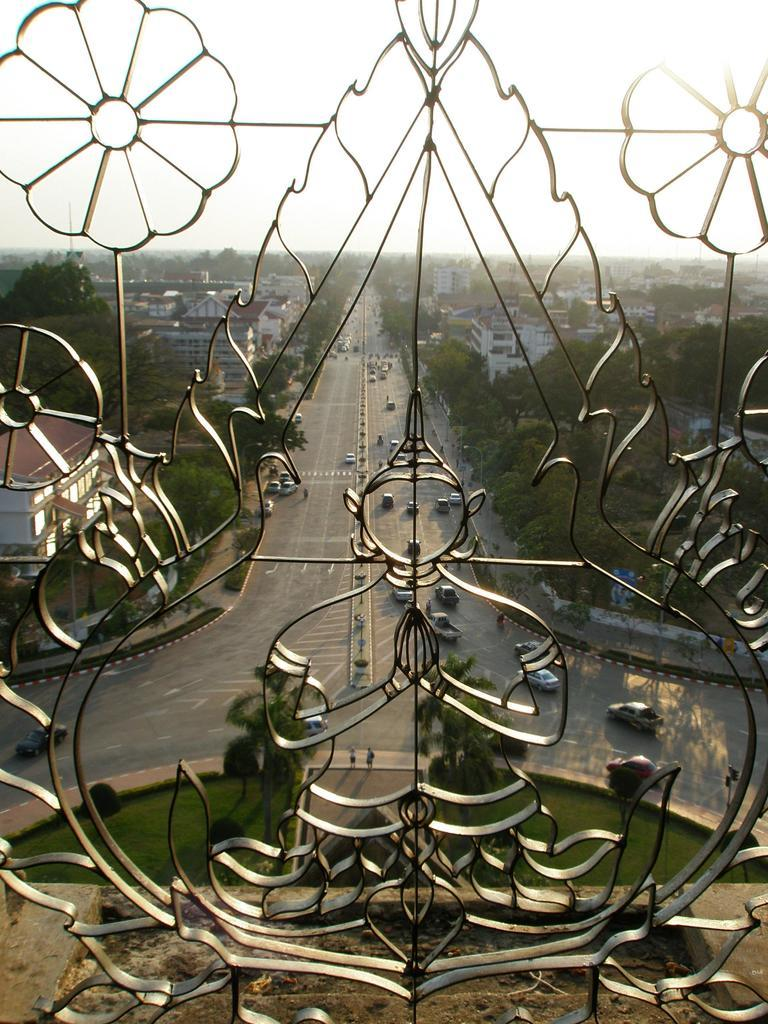What type of structure can be seen in the image? There are iron bars in the image, which suggests a fence or gate. What can be seen in the distance behind the iron bars? There are vehicles, trees, and buildings visible in the background of the image. What type of terrain is visible in the image? There is grass visible in the image. Can you tell me how many loaves of bread are on the actor's head in the image? There is no actor or loaves of bread present in the image. 